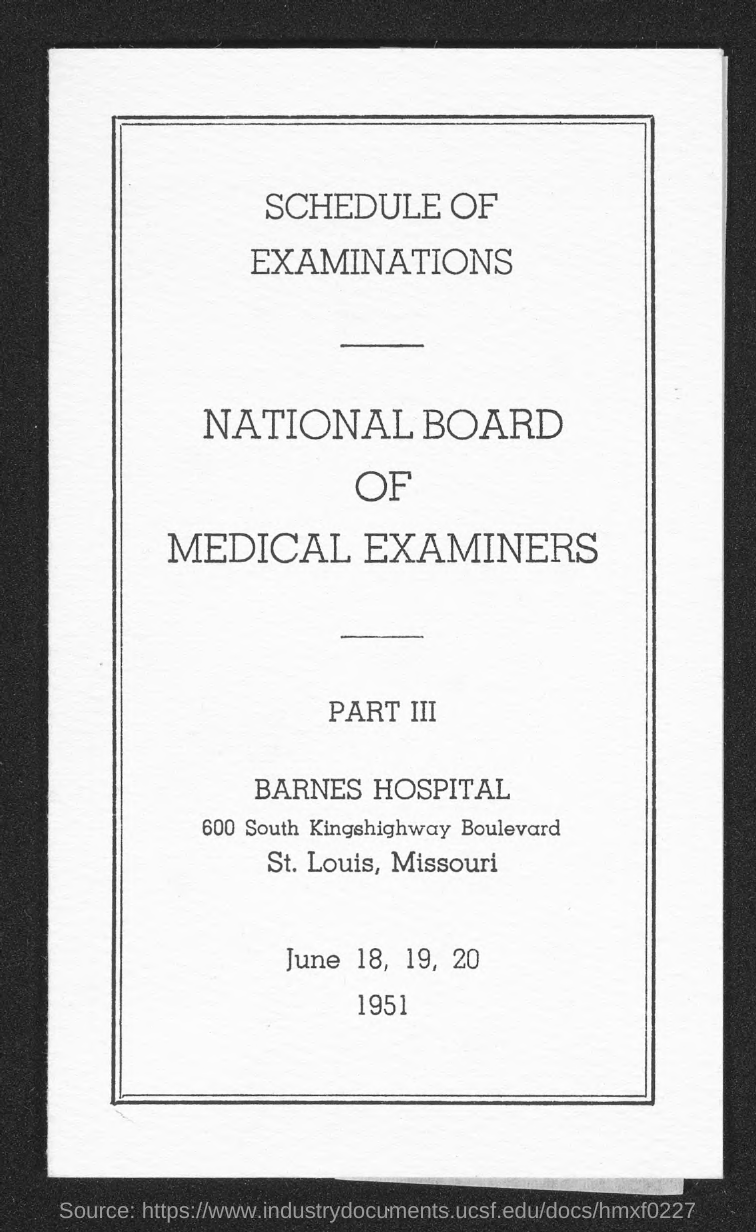In which state is barnes hospital at ?
Give a very brief answer. Missouri. 